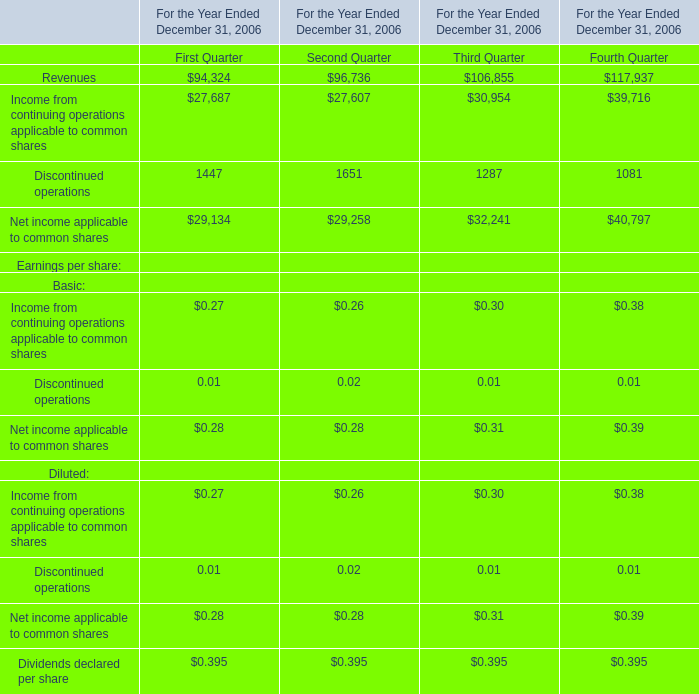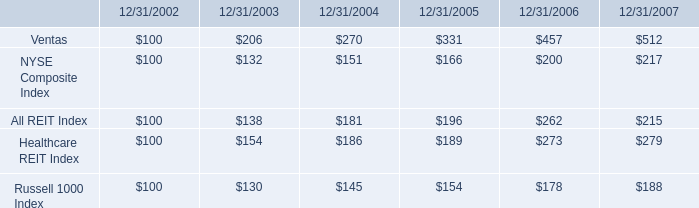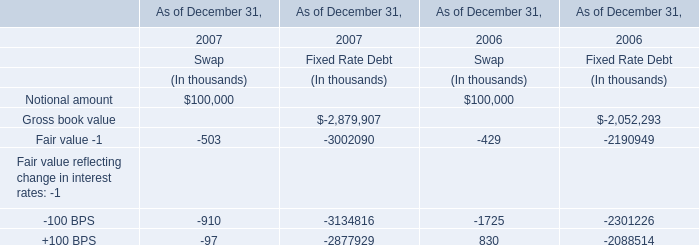what was the growth rate of reit index as of 12/31/2003 
Computations: ((138 - 100) / 100)
Answer: 0.38. 